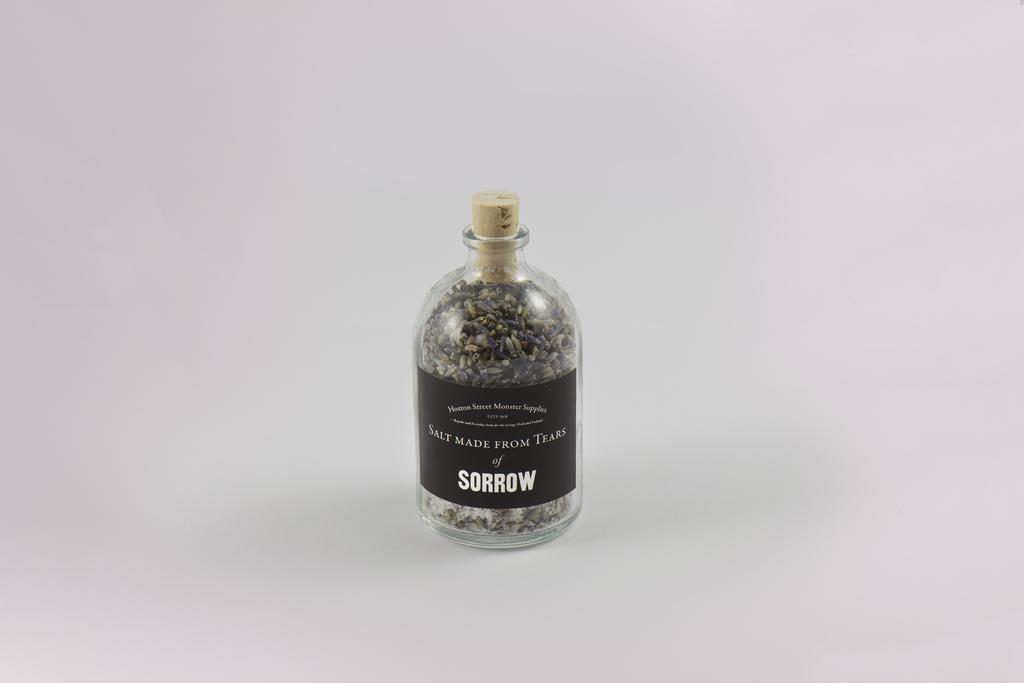What is the salt made from?
Give a very brief answer. Tears of sorrow. The brand of this is?
Provide a short and direct response. Hoxton street monster supplies. 